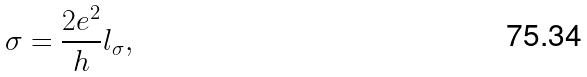<formula> <loc_0><loc_0><loc_500><loc_500>\sigma = \frac { 2 e ^ { 2 } } { h } l _ { \sigma } ,</formula> 